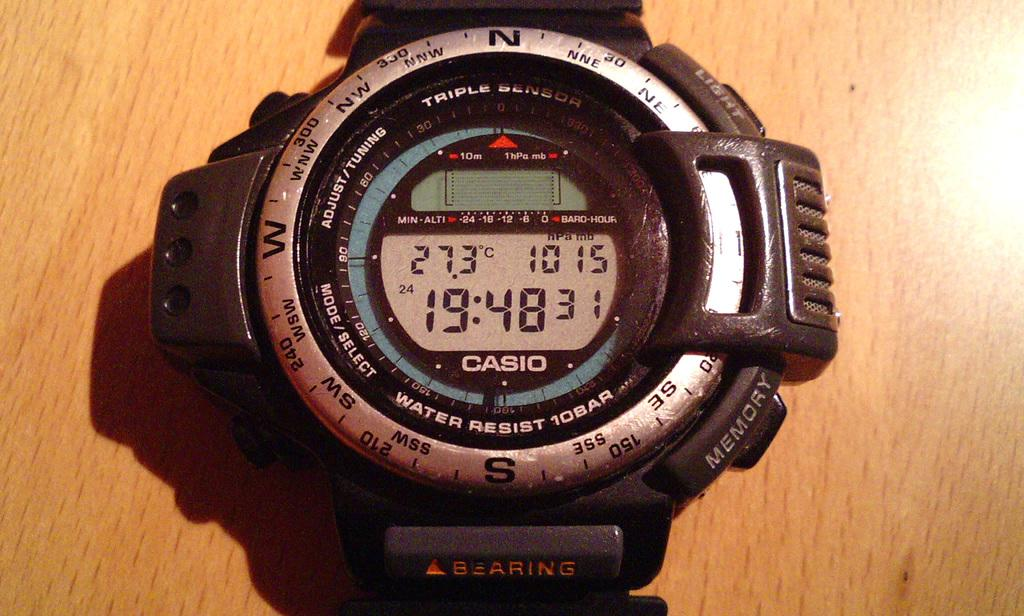<image>
Give a short and clear explanation of the subsequent image. The digital watch here is from the company Casio 